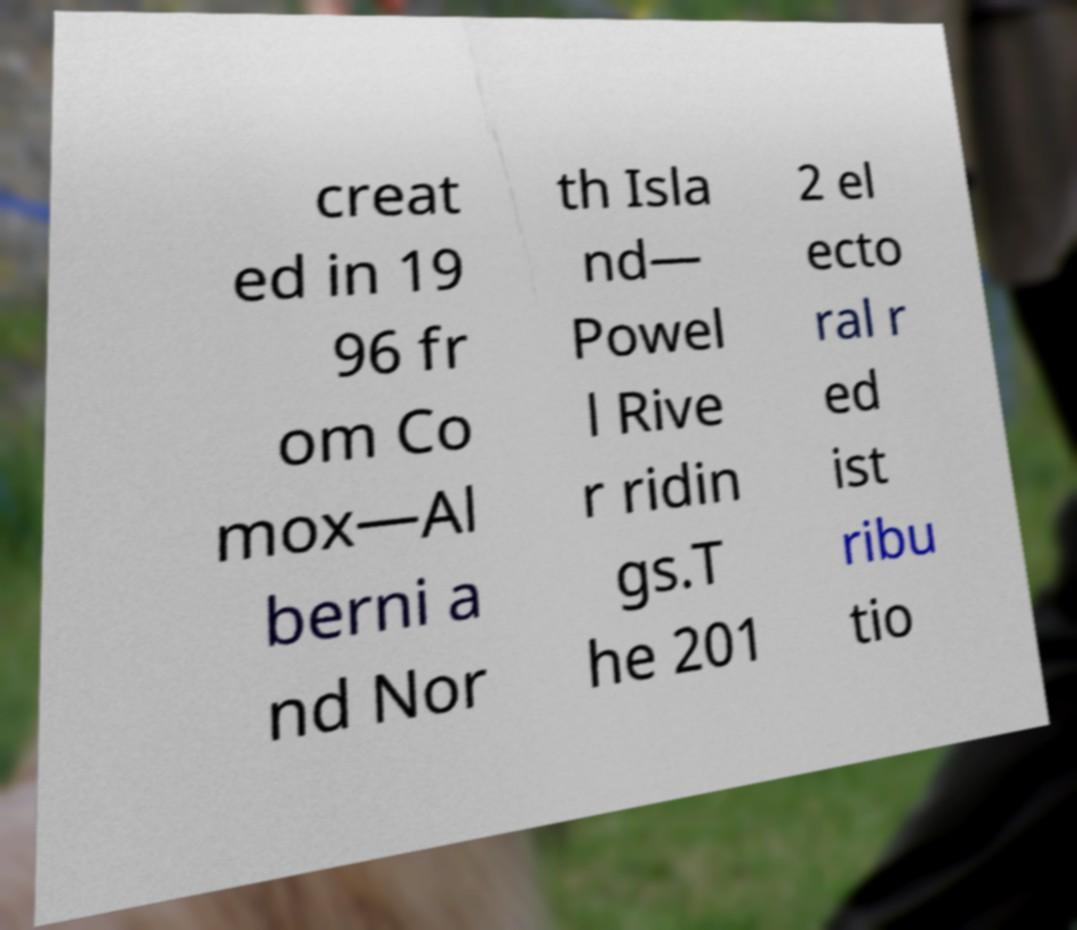Please read and relay the text visible in this image. What does it say? creat ed in 19 96 fr om Co mox—Al berni a nd Nor th Isla nd— Powel l Rive r ridin gs.T he 201 2 el ecto ral r ed ist ribu tio 